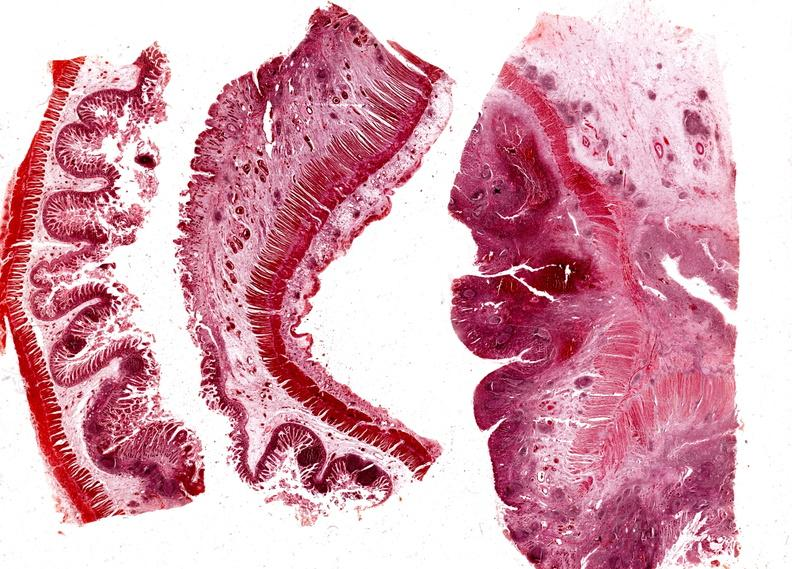s gastrointestinal present?
Answer the question using a single word or phrase. Yes 